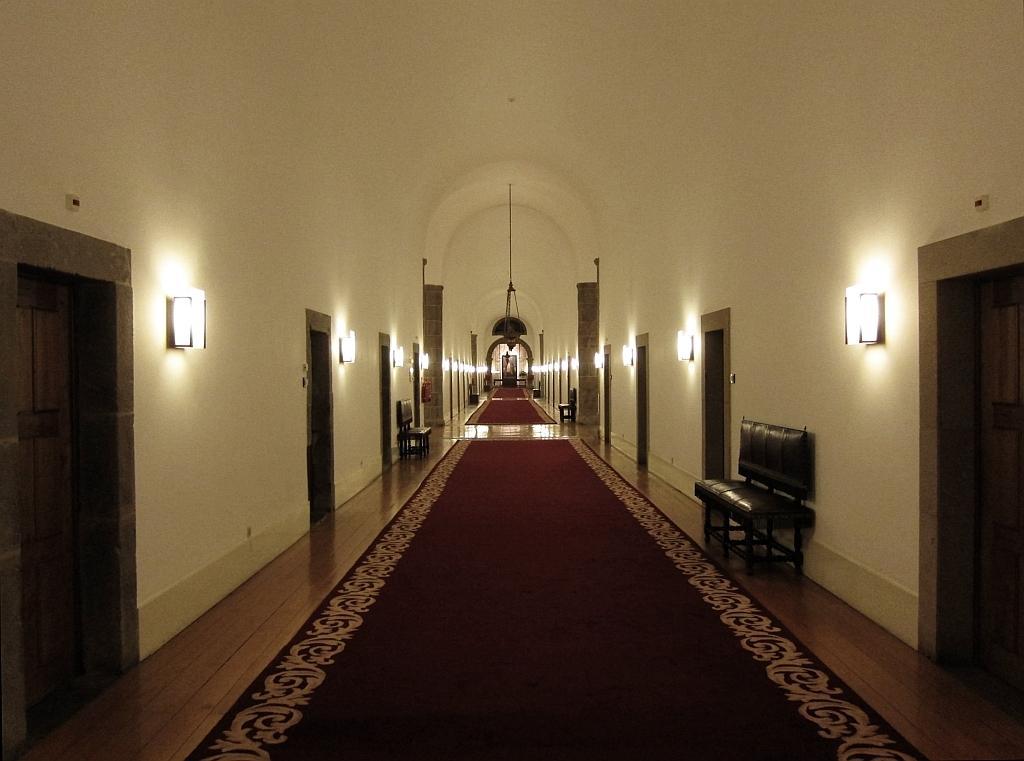Could you give a brief overview of what you see in this image? There are doors and a rug on the floor in the foreground area of the image, there are doors, sofas, lamps, it seems like a chandelier and an arch in the background. 